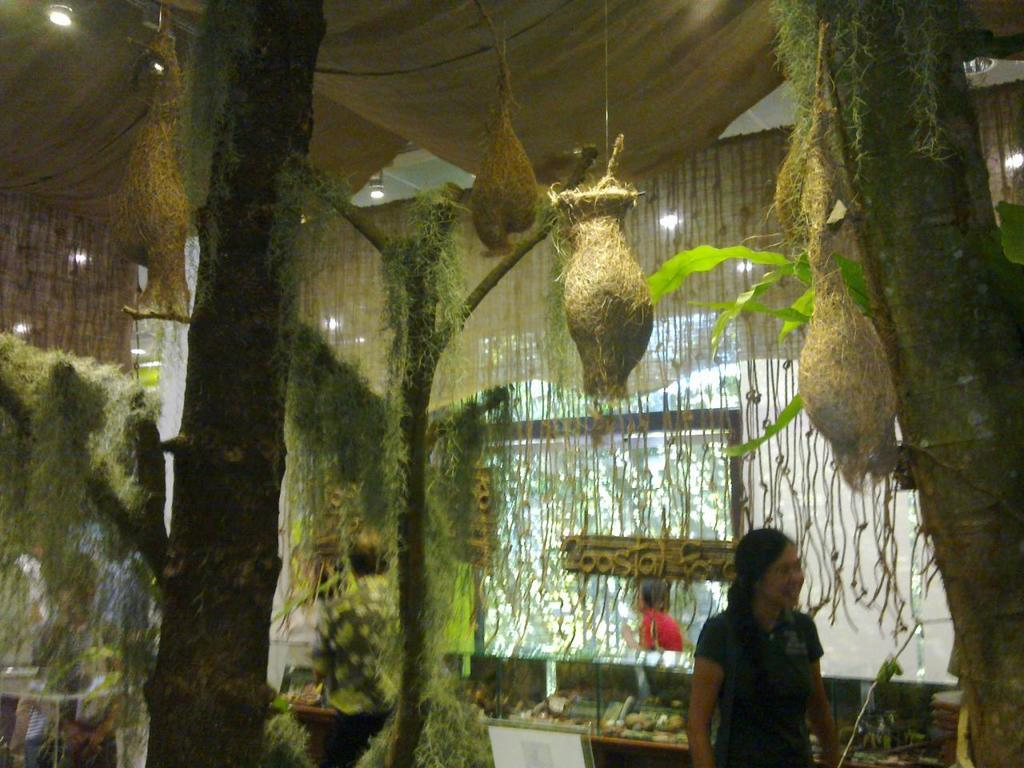Who is present in the image? There is a lady in the image. Where is the lady located in the image? The lady is at the bottom side of the image. What can be seen in the image besides the lady? There are nests in the image. How many trunks are visible on each side of the image? There are two trunks on the right side of the image and two trunks on the left side of the image. What type of basketball game is being played in the image? There is no basketball game present in the image. What is the mass of the lady in the image? It is not possible to determine the mass of the lady from the image alone. 